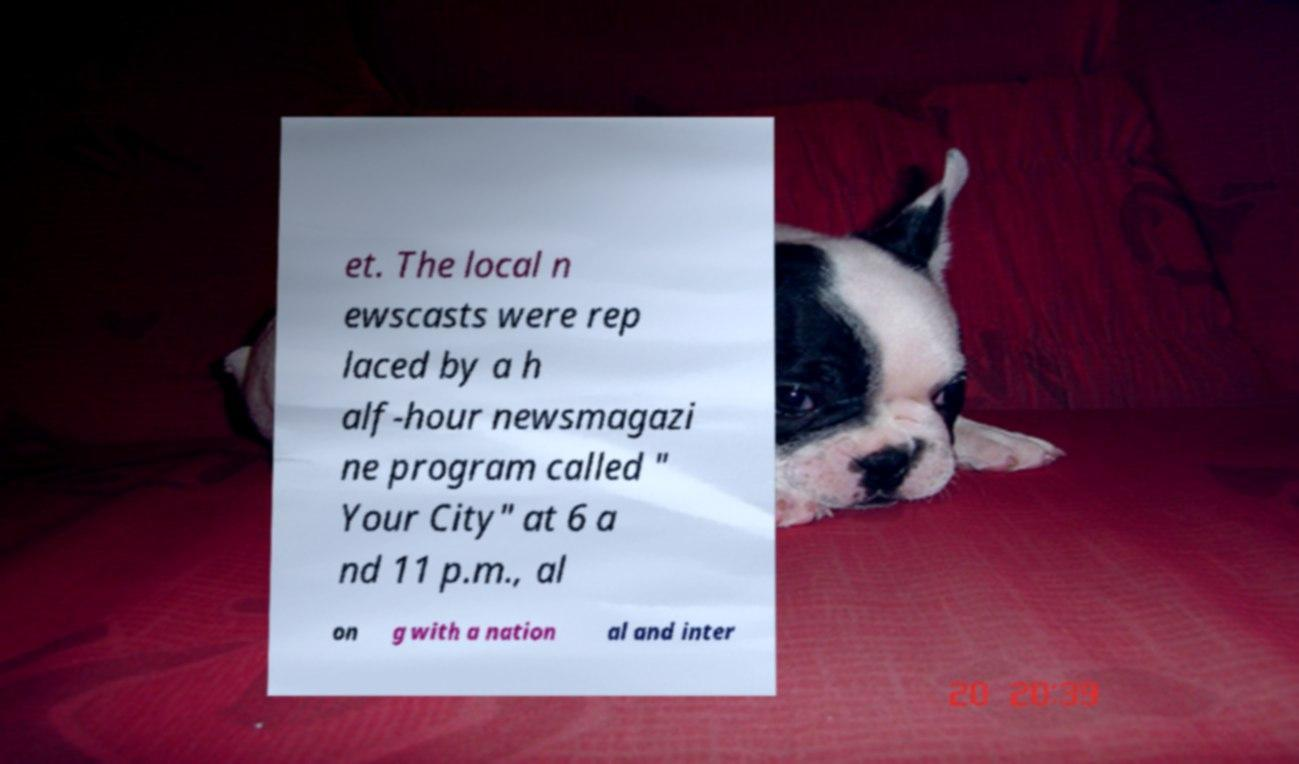I need the written content from this picture converted into text. Can you do that? et. The local n ewscasts were rep laced by a h alf-hour newsmagazi ne program called " Your City" at 6 a nd 11 p.m., al on g with a nation al and inter 